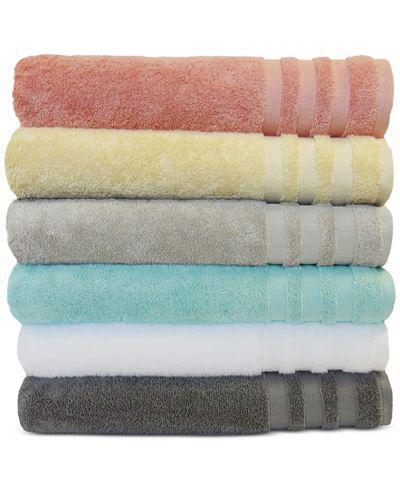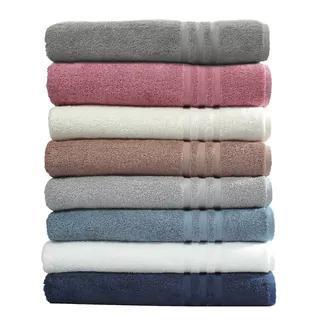The first image is the image on the left, the second image is the image on the right. Considering the images on both sides, is "There are more towels in the right image than in the left image." valid? Answer yes or no. Yes. The first image is the image on the left, the second image is the image on the right. Examine the images to the left and right. Is the description "There are ten towels." accurate? Answer yes or no. No. 